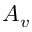<formula> <loc_0><loc_0><loc_500><loc_500>A _ { v }</formula> 